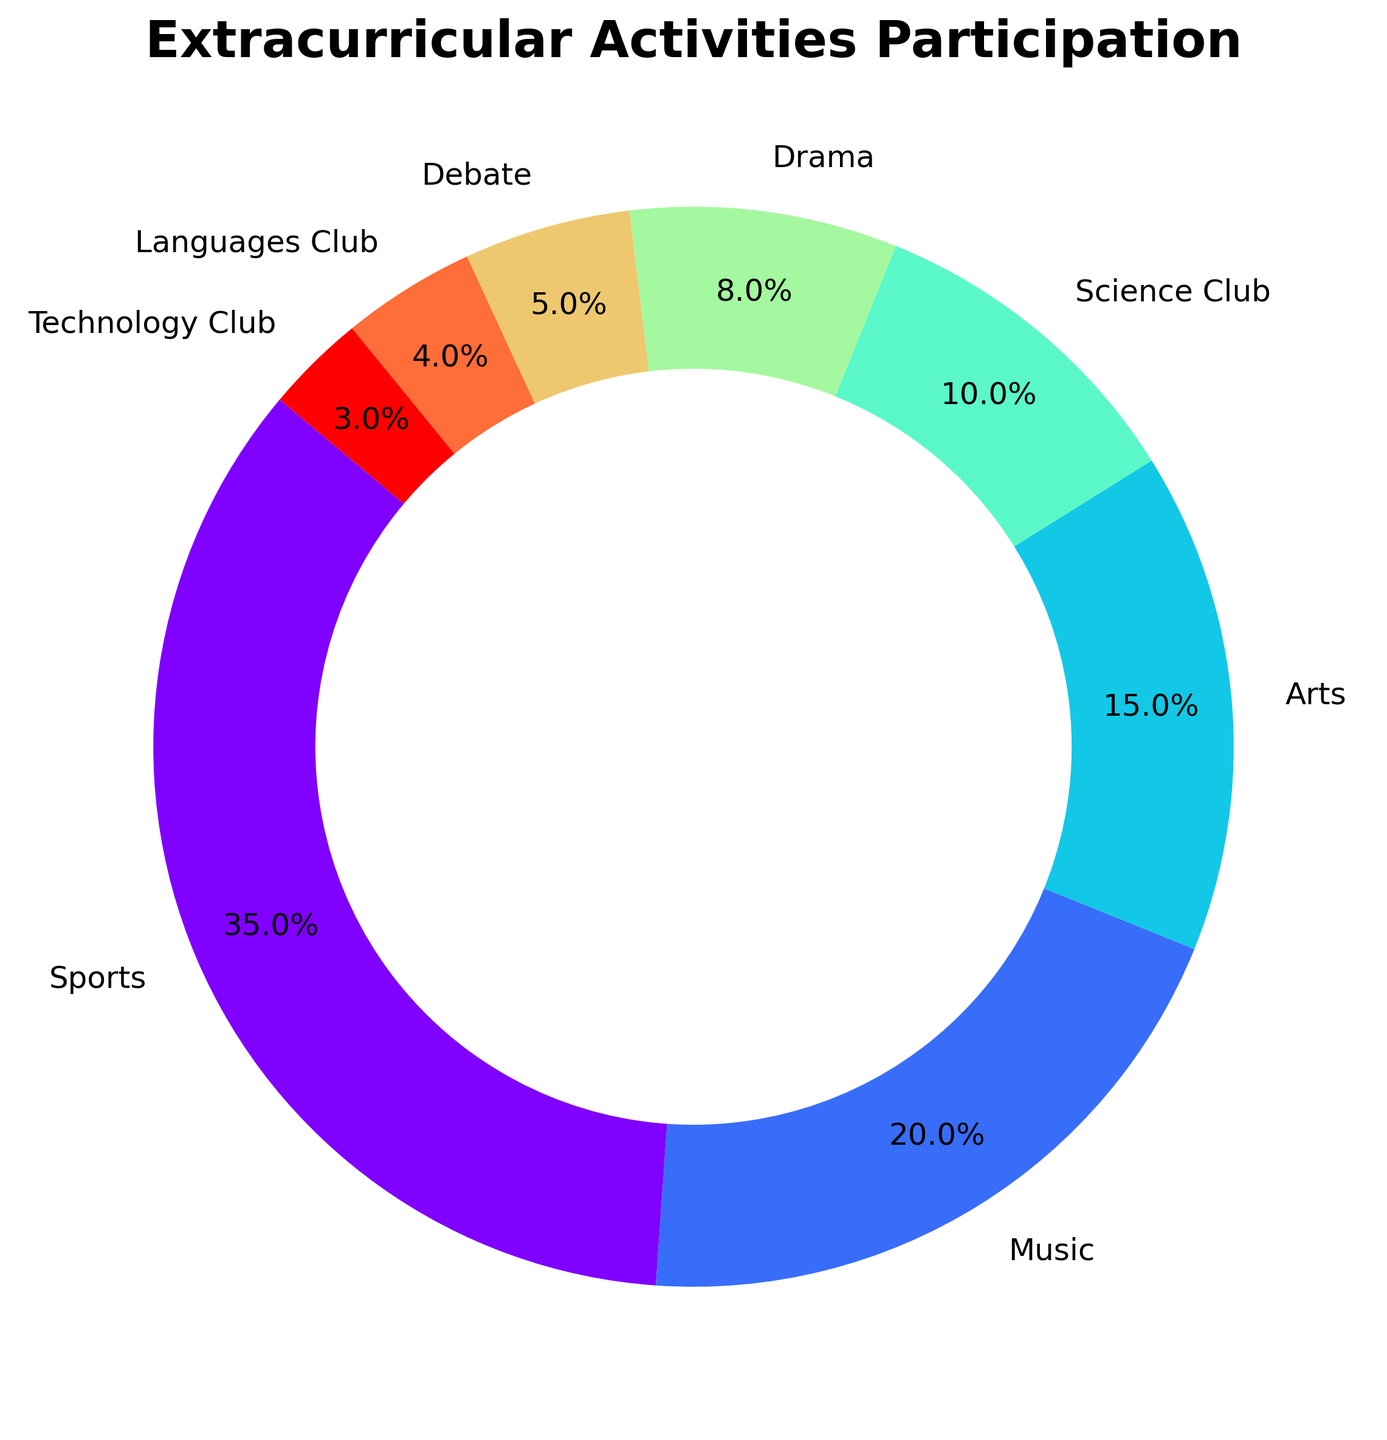Which activity type has the highest participation percentage? The ring chart shows multiple activity types with their participation percentages. By visual inspection, the segment with the label "Sports" looks the largest, and if we look at the percentage values, "Sports" has the highest at 35%.
Answer: Sports What's the total participation percentage for Music and Arts combined? From the chart, "Music" has a participation percentage of 20%, and "Arts" is at 15%. Adding these together gives 20% + 15% = 35%.
Answer: 35% How much greater is the participation percentage in Drama compared to Debate? The participation percentage for "Drama" is 8%, and for "Debate" it is 5%. To find the difference, we subtract the smaller percentage from the larger one: 8% - 5% = 3%.
Answer: 3% Rank the activities from highest to lowest participation percentage. By looking at the ring chart, we can list the activities based on their participation percentages from highest to lowest as follows: Sports (35%), Music (20%), Arts (15%), Science Club (10%), Drama (8%), Debate (5%), Languages Club (4%), Technology Club (3%).
Answer: Sports, Music, Arts, Science Club, Drama, Debate, Languages Club, Technology Club What is the average participation percentage of the top three activities? The top three activities by participation percentage are Sports (35%), Music (20%), and Arts (15%). To find the average, sum these percentages and divide by 3: (35% + 20% + 15%) / 3 = 70% / 3 ≈ 23.33%.
Answer: ≈ 23.33% Which activities have a participation percentage less than 10%? By examining the ring chart, the activities with participation percentages less than 10% are Science Club (10%), Drama (8%), Debate (5%), Languages Club (4%), and Technology Club (3%).
Answer: Drama, Debate, Languages Club, Technology Club What is the combined participation percentage of activities in Science Club and Technology Club? The participation percentage of "Science Club" is 10%, and that of "Technology Club" is 3%. Adding these together, we get 10% + 3% = 13%.
Answer: 13% How does the participation in Music compare with the participation in Debate? The participation percentage for "Music" is 20%, whereas for "Debate" it is 5%. Music participation is 20% - 5% = 15% higher than Debate participation.
Answer: 15% What section is represented by the smallest slice in the chart? By looking at the ring chart, the smallest slice is represented by "Technology Club," which has a participation percentage of 3%.
Answer: Technology Club 